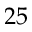Convert formula to latex. <formula><loc_0><loc_0><loc_500><loc_500>2 5</formula> 